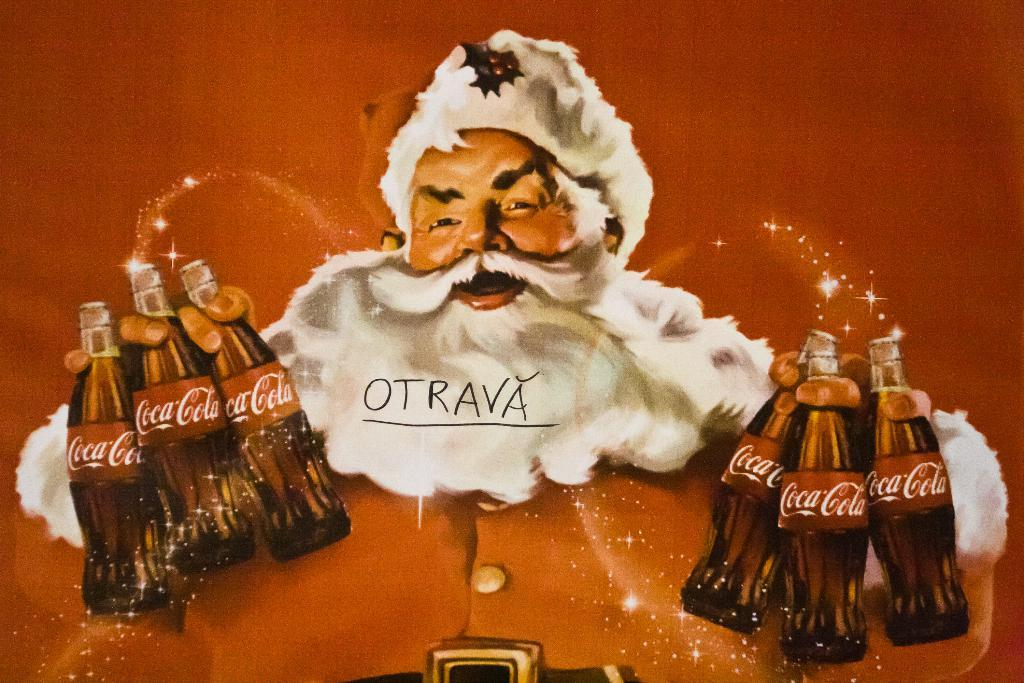What is present in the image? There is a person in the image. What is the person holding in his hand? The person is holding bottles in his hand. Can you see a lake in the background of the image? There is no lake visible in the image; it only shows a person holding bottles in his hand. 